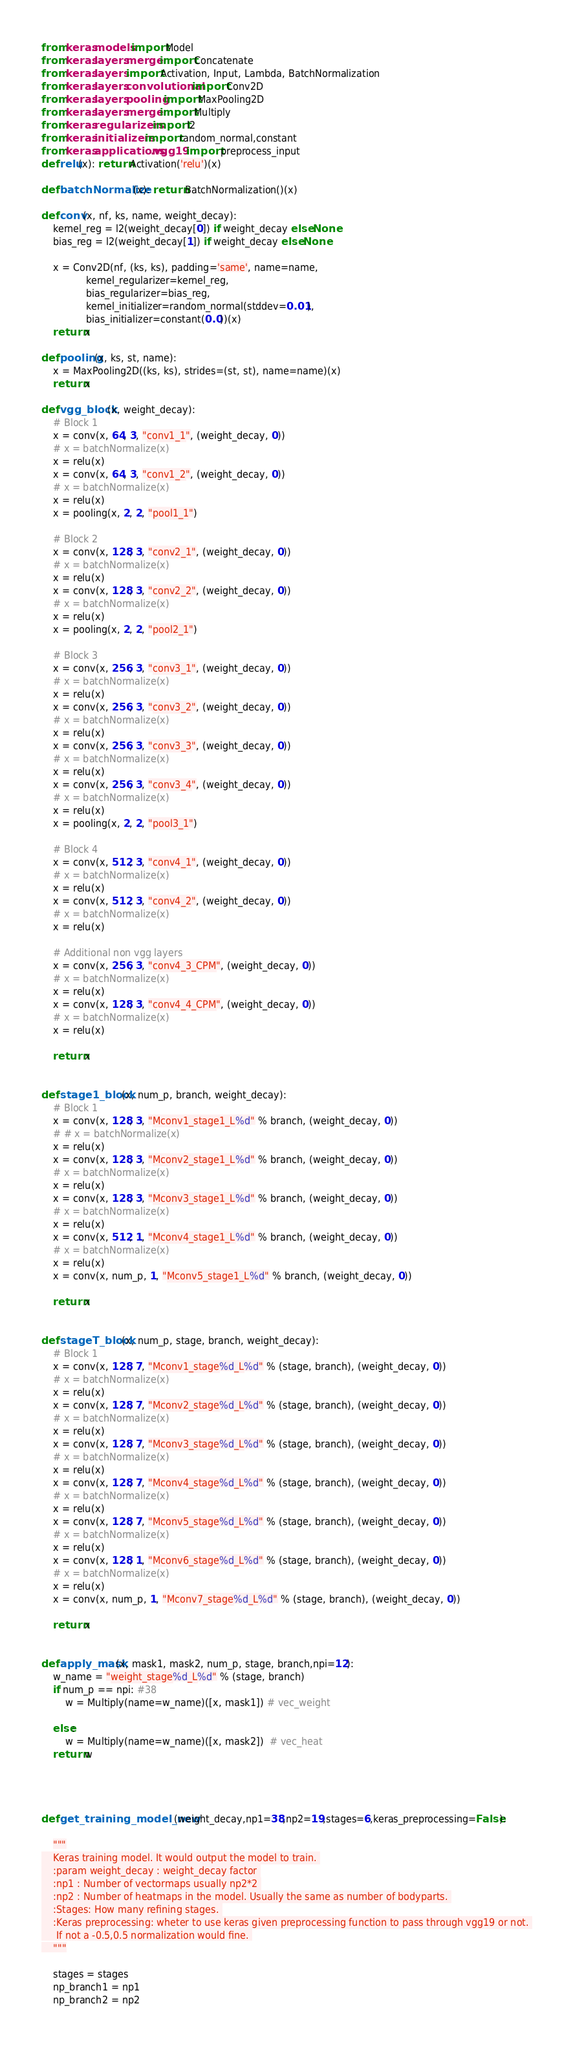<code> <loc_0><loc_0><loc_500><loc_500><_Python_>from keras.models import Model
from keras.layers.merge import Concatenate
from keras.layers import Activation, Input, Lambda, BatchNormalization
from keras.layers.convolutional import Conv2D
from keras.layers.pooling import MaxPooling2D
from keras.layers.merge import Multiply
from keras.regularizers import l2
from keras.initializers import random_normal,constant
from keras.applications.vgg19 import preprocess_input
def relu(x): return Activation('relu')(x)

def batchNormalize(x): return BatchNormalization()(x)

def conv(x, nf, ks, name, weight_decay):
    kernel_reg = l2(weight_decay[0]) if weight_decay else None
    bias_reg = l2(weight_decay[1]) if weight_decay else None

    x = Conv2D(nf, (ks, ks), padding='same', name=name,
               kernel_regularizer=kernel_reg,
               bias_regularizer=bias_reg,
               kernel_initializer=random_normal(stddev=0.01),
               bias_initializer=constant(0.0))(x)
    return x

def pooling(x, ks, st, name):
    x = MaxPooling2D((ks, ks), strides=(st, st), name=name)(x)
    return x

def vgg_block(x, weight_decay):
    # Block 1
    x = conv(x, 64, 3, "conv1_1", (weight_decay, 0))
    # x = batchNormalize(x)
    x = relu(x)
    x = conv(x, 64, 3, "conv1_2", (weight_decay, 0))
    # x = batchNormalize(x)
    x = relu(x)
    x = pooling(x, 2, 2, "pool1_1")

    # Block 2
    x = conv(x, 128, 3, "conv2_1", (weight_decay, 0))
    # x = batchNormalize(x)
    x = relu(x)
    x = conv(x, 128, 3, "conv2_2", (weight_decay, 0))
    # x = batchNormalize(x)
    x = relu(x)
    x = pooling(x, 2, 2, "pool2_1")

    # Block 3
    x = conv(x, 256, 3, "conv3_1", (weight_decay, 0))
    # x = batchNormalize(x)
    x = relu(x)
    x = conv(x, 256, 3, "conv3_2", (weight_decay, 0))
    # x = batchNormalize(x)
    x = relu(x)
    x = conv(x, 256, 3, "conv3_3", (weight_decay, 0))
    # x = batchNormalize(x)
    x = relu(x)
    x = conv(x, 256, 3, "conv3_4", (weight_decay, 0))
    # x = batchNormalize(x)
    x = relu(x)
    x = pooling(x, 2, 2, "pool3_1")

    # Block 4
    x = conv(x, 512, 3, "conv4_1", (weight_decay, 0))
    # x = batchNormalize(x)
    x = relu(x)
    x = conv(x, 512, 3, "conv4_2", (weight_decay, 0))
    # x = batchNormalize(x)
    x = relu(x)

    # Additional non vgg layers
    x = conv(x, 256, 3, "conv4_3_CPM", (weight_decay, 0))
    # x = batchNormalize(x)
    x = relu(x)
    x = conv(x, 128, 3, "conv4_4_CPM", (weight_decay, 0))
    # x = batchNormalize(x)
    x = relu(x)

    return x


def stage1_block(x, num_p, branch, weight_decay):
    # Block 1
    x = conv(x, 128, 3, "Mconv1_stage1_L%d" % branch, (weight_decay, 0))
    # # x = batchNormalize(x)
    x = relu(x)
    x = conv(x, 128, 3, "Mconv2_stage1_L%d" % branch, (weight_decay, 0))
    # x = batchNormalize(x)
    x = relu(x)
    x = conv(x, 128, 3, "Mconv3_stage1_L%d" % branch, (weight_decay, 0))
    # x = batchNormalize(x)
    x = relu(x)
    x = conv(x, 512, 1, "Mconv4_stage1_L%d" % branch, (weight_decay, 0))
    # x = batchNormalize(x)
    x = relu(x)
    x = conv(x, num_p, 1, "Mconv5_stage1_L%d" % branch, (weight_decay, 0))

    return x


def stageT_block(x, num_p, stage, branch, weight_decay):
    # Block 1
    x = conv(x, 128, 7, "Mconv1_stage%d_L%d" % (stage, branch), (weight_decay, 0))
    # x = batchNormalize(x)
    x = relu(x)
    x = conv(x, 128, 7, "Mconv2_stage%d_L%d" % (stage, branch), (weight_decay, 0))
    # x = batchNormalize(x)
    x = relu(x)
    x = conv(x, 128, 7, "Mconv3_stage%d_L%d" % (stage, branch), (weight_decay, 0))
    # x = batchNormalize(x)
    x = relu(x)
    x = conv(x, 128, 7, "Mconv4_stage%d_L%d" % (stage, branch), (weight_decay, 0))
    # x = batchNormalize(x)
    x = relu(x)
    x = conv(x, 128, 7, "Mconv5_stage%d_L%d" % (stage, branch), (weight_decay, 0))
    # x = batchNormalize(x)
    x = relu(x)
    x = conv(x, 128, 1, "Mconv6_stage%d_L%d" % (stage, branch), (weight_decay, 0))
    # x = batchNormalize(x)
    x = relu(x)
    x = conv(x, num_p, 1, "Mconv7_stage%d_L%d" % (stage, branch), (weight_decay, 0))

    return x


def apply_mask(x, mask1, mask2, num_p, stage, branch,npi=12):
    w_name = "weight_stage%d_L%d" % (stage, branch)
    if num_p == npi: #38
        w = Multiply(name=w_name)([x, mask1]) # vec_weight

    else:
        w = Multiply(name=w_name)([x, mask2])  # vec_heat
    return w




def get_training_model_new(weight_decay,np1=38,np2=19,stages=6,keras_preprocessing=False):

    """
    Keras training model. It would output the model to train. 
    :param weight_decay : weight_decay factor 
    :np1 : Number of vectormaps usually np2*2 
    :np2 : Number of heatmaps in the model. Usually the same as number of bodyparts. 
    :Stages: How many refining stages. 
    :Keras preprocessing: wheter to use keras given preprocessing function to pass through vgg19 or not. 
     If not a -0.5,0.5 normalization would fine. 
    """

    stages = stages
    np_branch1 = np1
    np_branch2 = np2
</code> 